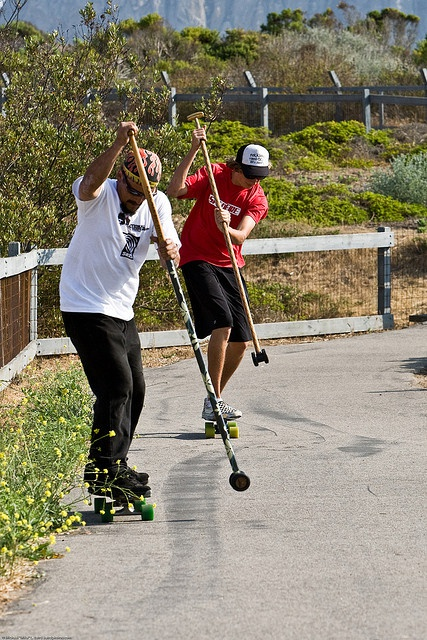Describe the objects in this image and their specific colors. I can see people in lightgray, black, darkgray, and white tones, people in lightgray, maroon, black, and white tones, skateboard in lightgray, black, darkgreen, and gray tones, and skateboard in lightgray, black, darkgreen, and khaki tones in this image. 